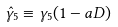Convert formula to latex. <formula><loc_0><loc_0><loc_500><loc_500>\hat { \gamma } _ { 5 } \equiv \gamma _ { 5 } ( 1 - a D )</formula> 